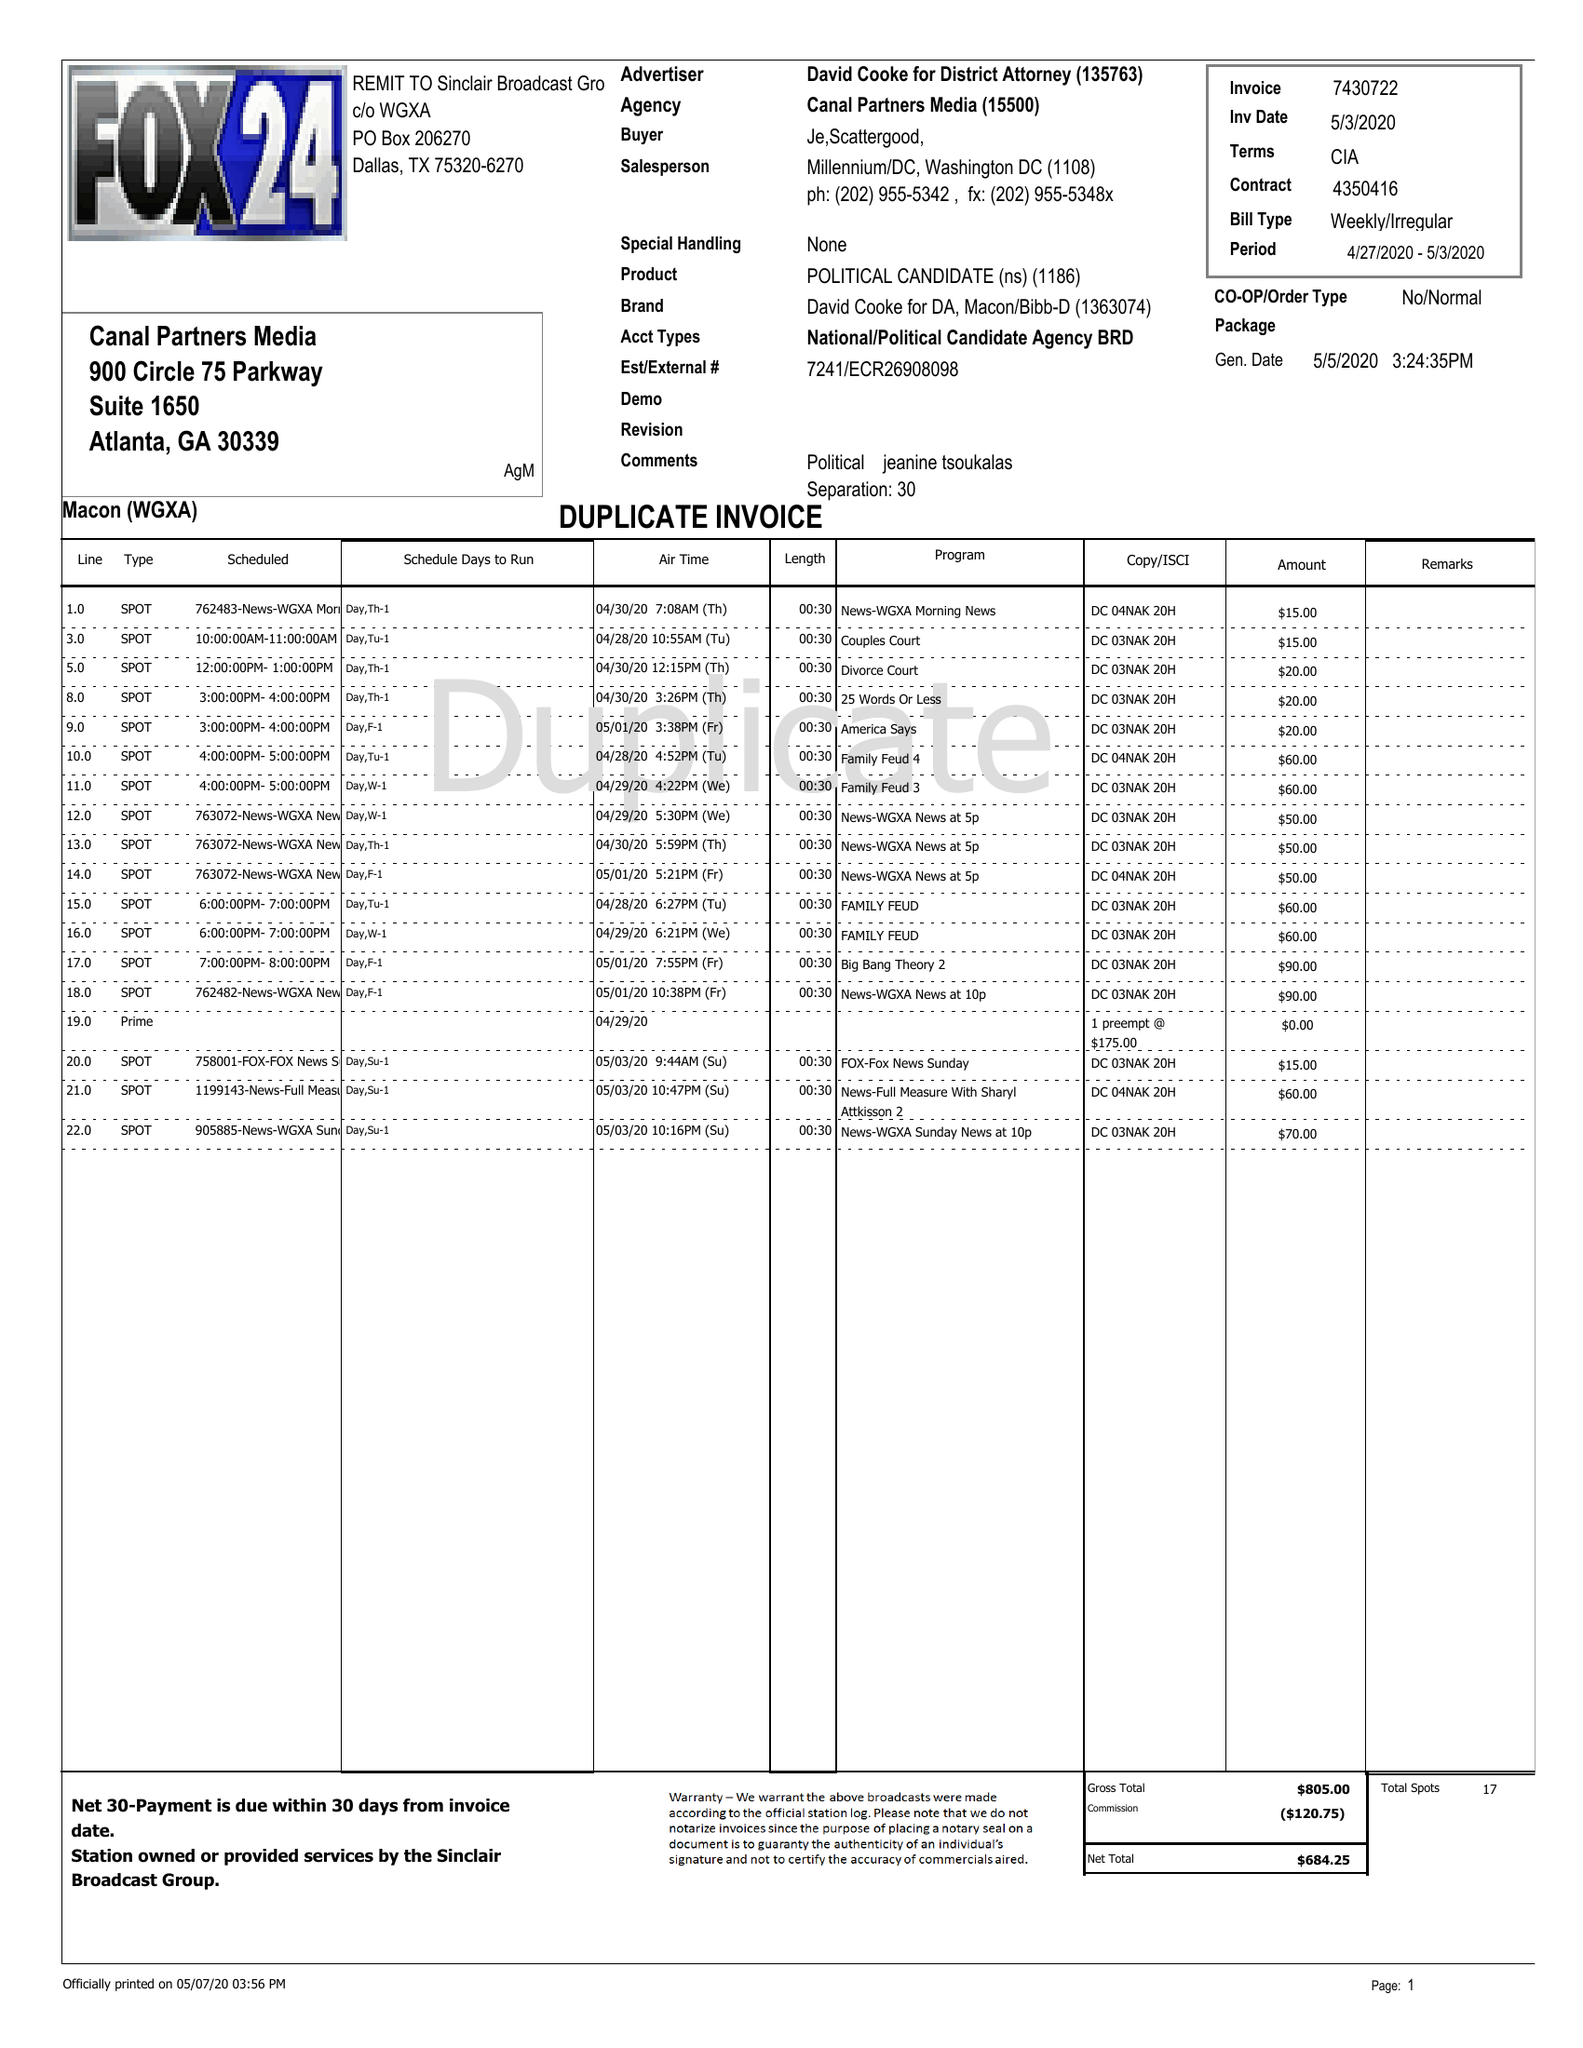What is the value for the contract_num?
Answer the question using a single word or phrase. 4350416 